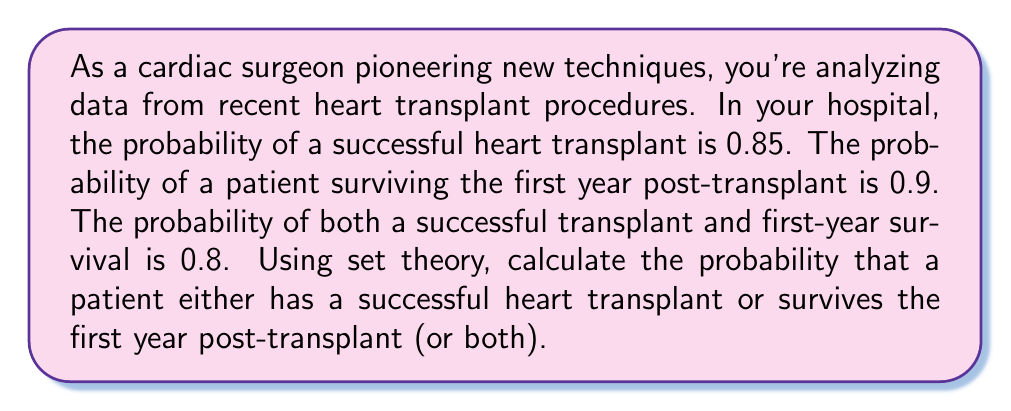Provide a solution to this math problem. Let's approach this step-by-step using set theory:

1) Define our sets:
   $A$ = event of a successful heart transplant
   $B$ = event of surviving the first year post-transplant

2) Given probabilities:
   $P(A) = 0.85$
   $P(B) = 0.9$
   $P(A \cap B) = 0.8$

3) We want to find $P(A \cup B)$, which is the probability of either A or B (or both) occurring.

4) We can use the addition rule of probability:
   $P(A \cup B) = P(A) + P(B) - P(A \cap B)$

5) This rule works because simply adding $P(A)$ and $P(B)$ would count the intersection twice, so we need to subtract it once.

6) Substituting our known values:
   $P(A \cup B) = 0.85 + 0.9 - 0.8$

7) Calculating:
   $P(A \cup B) = 1.75 - 0.8 = 0.95$

Therefore, the probability that a patient either has a successful heart transplant or survives the first year post-transplant (or both) is 0.95 or 95%.
Answer: $P(A \cup B) = 0.95$ or 95% 